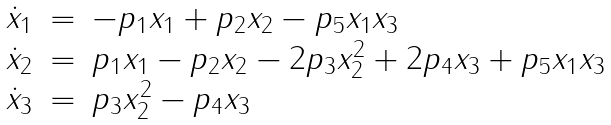Convert formula to latex. <formula><loc_0><loc_0><loc_500><loc_500>\begin{array} { r c l } \dot { x } _ { 1 } & = & - p _ { 1 } x _ { 1 } + p _ { 2 } x _ { 2 } - p _ { 5 } x _ { 1 } x _ { 3 } \\ \dot { x } _ { 2 } & = & p _ { 1 } x _ { 1 } - p _ { 2 } x _ { 2 } - 2 p _ { 3 } x _ { 2 } ^ { 2 } + 2 p _ { 4 } x _ { 3 } + p _ { 5 } x _ { 1 } x _ { 3 } \\ \dot { x } _ { 3 } & = & p _ { 3 } x _ { 2 } ^ { 2 } - p _ { 4 } x _ { 3 } \\ \end{array}</formula> 